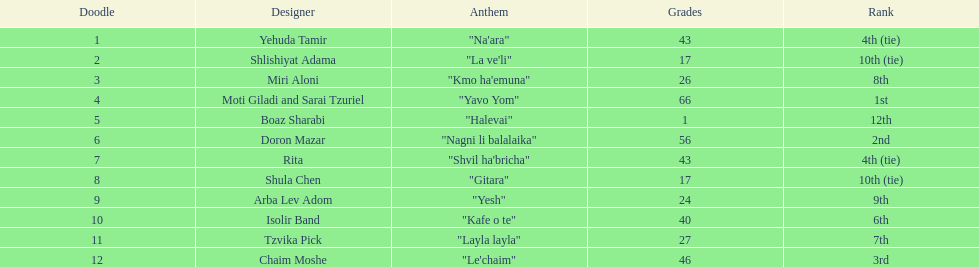Did the song "gitara" or "yesh" earn more points? "Yesh". 